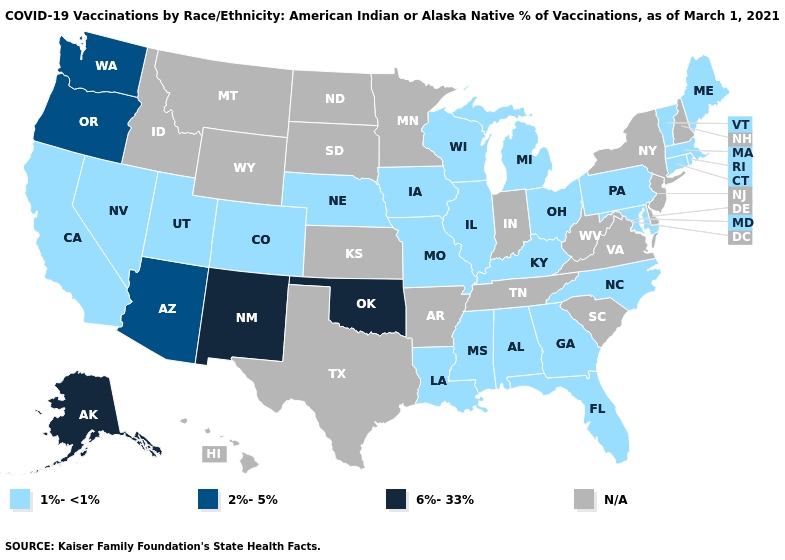What is the value of Delaware?
Answer briefly. N/A. Which states hav the highest value in the MidWest?
Give a very brief answer. Illinois, Iowa, Michigan, Missouri, Nebraska, Ohio, Wisconsin. Among the states that border New Mexico , which have the highest value?
Answer briefly. Oklahoma. What is the highest value in the West ?
Be succinct. 6%-33%. Name the states that have a value in the range N/A?
Write a very short answer. Arkansas, Delaware, Hawaii, Idaho, Indiana, Kansas, Minnesota, Montana, New Hampshire, New Jersey, New York, North Dakota, South Carolina, South Dakota, Tennessee, Texas, Virginia, West Virginia, Wyoming. Among the states that border Vermont , which have the lowest value?
Answer briefly. Massachusetts. Name the states that have a value in the range N/A?
Write a very short answer. Arkansas, Delaware, Hawaii, Idaho, Indiana, Kansas, Minnesota, Montana, New Hampshire, New Jersey, New York, North Dakota, South Carolina, South Dakota, Tennessee, Texas, Virginia, West Virginia, Wyoming. What is the highest value in the USA?
Keep it brief. 6%-33%. What is the highest value in states that border Tennessee?
Keep it brief. 1%-<1%. Among the states that border Washington , which have the lowest value?
Be succinct. Oregon. What is the value of New Mexico?
Concise answer only. 6%-33%. Does the first symbol in the legend represent the smallest category?
Be succinct. Yes. What is the value of Pennsylvania?
Quick response, please. 1%-<1%. How many symbols are there in the legend?
Concise answer only. 4. 